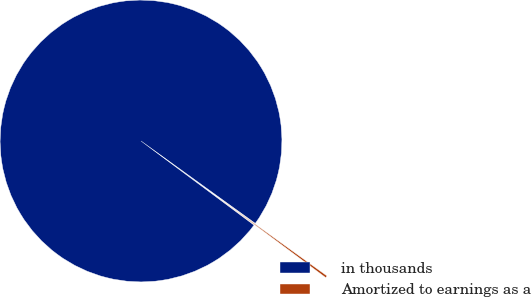<chart> <loc_0><loc_0><loc_500><loc_500><pie_chart><fcel>in thousands<fcel>Amortized to earnings as a<nl><fcel>99.76%<fcel>0.24%<nl></chart> 